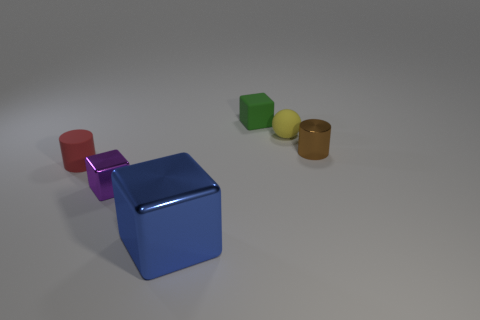Subtract all shiny blocks. How many blocks are left? 1 Add 1 big green cubes. How many objects exist? 7 Subtract all purple blocks. How many blocks are left? 2 Subtract 2 cubes. How many cubes are left? 1 Add 1 gray rubber things. How many gray rubber things exist? 1 Subtract 0 red spheres. How many objects are left? 6 Subtract all cylinders. How many objects are left? 4 Subtract all blue cylinders. Subtract all brown blocks. How many cylinders are left? 2 Subtract all brown balls. How many red cubes are left? 0 Subtract all large blue metal spheres. Subtract all tiny matte blocks. How many objects are left? 5 